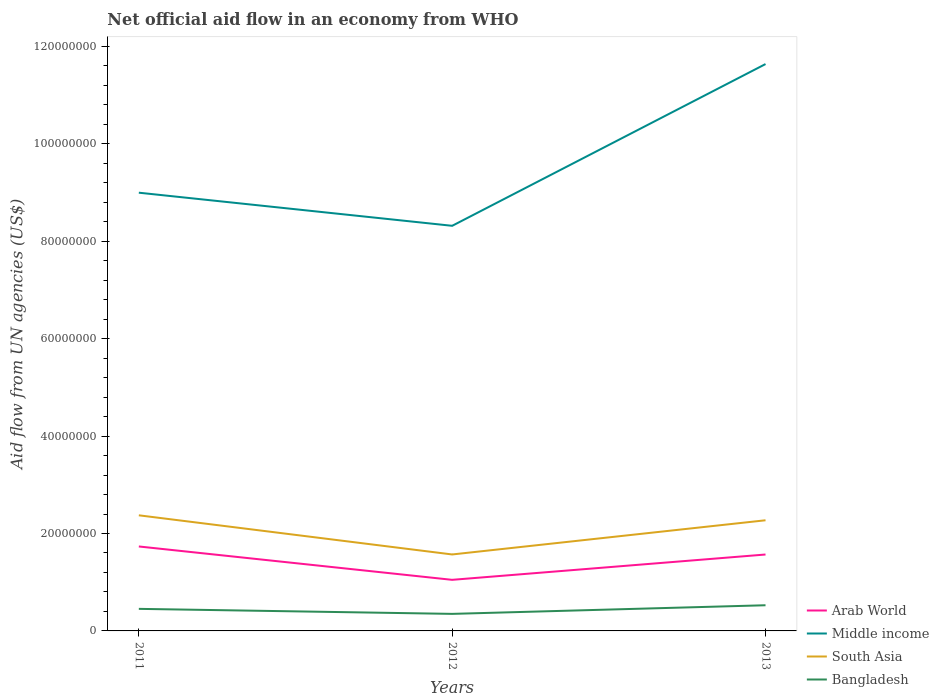Is the number of lines equal to the number of legend labels?
Give a very brief answer. Yes. Across all years, what is the maximum net official aid flow in Bangladesh?
Offer a terse response. 3.50e+06. What is the total net official aid flow in South Asia in the graph?
Give a very brief answer. -7.02e+06. What is the difference between the highest and the second highest net official aid flow in South Asia?
Your response must be concise. 8.04e+06. What is the difference between the highest and the lowest net official aid flow in Arab World?
Offer a very short reply. 2. Is the net official aid flow in Middle income strictly greater than the net official aid flow in South Asia over the years?
Your response must be concise. No. How many lines are there?
Provide a short and direct response. 4. How many years are there in the graph?
Give a very brief answer. 3. Does the graph contain grids?
Give a very brief answer. No. How are the legend labels stacked?
Your answer should be compact. Vertical. What is the title of the graph?
Your answer should be very brief. Net official aid flow in an economy from WHO. Does "St. Martin (French part)" appear as one of the legend labels in the graph?
Your answer should be very brief. No. What is the label or title of the Y-axis?
Ensure brevity in your answer.  Aid flow from UN agencies (US$). What is the Aid flow from UN agencies (US$) of Arab World in 2011?
Ensure brevity in your answer.  1.73e+07. What is the Aid flow from UN agencies (US$) in Middle income in 2011?
Offer a very short reply. 9.00e+07. What is the Aid flow from UN agencies (US$) of South Asia in 2011?
Your answer should be very brief. 2.37e+07. What is the Aid flow from UN agencies (US$) in Bangladesh in 2011?
Ensure brevity in your answer.  4.53e+06. What is the Aid flow from UN agencies (US$) in Arab World in 2012?
Offer a terse response. 1.05e+07. What is the Aid flow from UN agencies (US$) in Middle income in 2012?
Keep it short and to the point. 8.32e+07. What is the Aid flow from UN agencies (US$) in South Asia in 2012?
Provide a succinct answer. 1.57e+07. What is the Aid flow from UN agencies (US$) of Bangladesh in 2012?
Offer a very short reply. 3.50e+06. What is the Aid flow from UN agencies (US$) in Arab World in 2013?
Offer a very short reply. 1.57e+07. What is the Aid flow from UN agencies (US$) of Middle income in 2013?
Keep it short and to the point. 1.16e+08. What is the Aid flow from UN agencies (US$) of South Asia in 2013?
Ensure brevity in your answer.  2.27e+07. What is the Aid flow from UN agencies (US$) of Bangladesh in 2013?
Ensure brevity in your answer.  5.27e+06. Across all years, what is the maximum Aid flow from UN agencies (US$) in Arab World?
Your answer should be very brief. 1.73e+07. Across all years, what is the maximum Aid flow from UN agencies (US$) in Middle income?
Your answer should be compact. 1.16e+08. Across all years, what is the maximum Aid flow from UN agencies (US$) of South Asia?
Your answer should be very brief. 2.37e+07. Across all years, what is the maximum Aid flow from UN agencies (US$) of Bangladesh?
Offer a terse response. 5.27e+06. Across all years, what is the minimum Aid flow from UN agencies (US$) in Arab World?
Keep it short and to the point. 1.05e+07. Across all years, what is the minimum Aid flow from UN agencies (US$) of Middle income?
Ensure brevity in your answer.  8.32e+07. Across all years, what is the minimum Aid flow from UN agencies (US$) in South Asia?
Offer a terse response. 1.57e+07. Across all years, what is the minimum Aid flow from UN agencies (US$) in Bangladesh?
Keep it short and to the point. 3.50e+06. What is the total Aid flow from UN agencies (US$) in Arab World in the graph?
Your answer should be very brief. 4.35e+07. What is the total Aid flow from UN agencies (US$) in Middle income in the graph?
Offer a very short reply. 2.90e+08. What is the total Aid flow from UN agencies (US$) of South Asia in the graph?
Offer a very short reply. 6.22e+07. What is the total Aid flow from UN agencies (US$) in Bangladesh in the graph?
Ensure brevity in your answer.  1.33e+07. What is the difference between the Aid flow from UN agencies (US$) of Arab World in 2011 and that in 2012?
Give a very brief answer. 6.85e+06. What is the difference between the Aid flow from UN agencies (US$) in Middle income in 2011 and that in 2012?
Provide a short and direct response. 6.80e+06. What is the difference between the Aid flow from UN agencies (US$) in South Asia in 2011 and that in 2012?
Keep it short and to the point. 8.04e+06. What is the difference between the Aid flow from UN agencies (US$) in Bangladesh in 2011 and that in 2012?
Provide a short and direct response. 1.03e+06. What is the difference between the Aid flow from UN agencies (US$) of Arab World in 2011 and that in 2013?
Keep it short and to the point. 1.65e+06. What is the difference between the Aid flow from UN agencies (US$) in Middle income in 2011 and that in 2013?
Make the answer very short. -2.64e+07. What is the difference between the Aid flow from UN agencies (US$) of South Asia in 2011 and that in 2013?
Provide a short and direct response. 1.02e+06. What is the difference between the Aid flow from UN agencies (US$) in Bangladesh in 2011 and that in 2013?
Ensure brevity in your answer.  -7.40e+05. What is the difference between the Aid flow from UN agencies (US$) of Arab World in 2012 and that in 2013?
Your response must be concise. -5.20e+06. What is the difference between the Aid flow from UN agencies (US$) in Middle income in 2012 and that in 2013?
Keep it short and to the point. -3.32e+07. What is the difference between the Aid flow from UN agencies (US$) of South Asia in 2012 and that in 2013?
Your answer should be very brief. -7.02e+06. What is the difference between the Aid flow from UN agencies (US$) of Bangladesh in 2012 and that in 2013?
Provide a succinct answer. -1.77e+06. What is the difference between the Aid flow from UN agencies (US$) in Arab World in 2011 and the Aid flow from UN agencies (US$) in Middle income in 2012?
Your answer should be compact. -6.58e+07. What is the difference between the Aid flow from UN agencies (US$) of Arab World in 2011 and the Aid flow from UN agencies (US$) of South Asia in 2012?
Give a very brief answer. 1.64e+06. What is the difference between the Aid flow from UN agencies (US$) of Arab World in 2011 and the Aid flow from UN agencies (US$) of Bangladesh in 2012?
Make the answer very short. 1.38e+07. What is the difference between the Aid flow from UN agencies (US$) in Middle income in 2011 and the Aid flow from UN agencies (US$) in South Asia in 2012?
Your response must be concise. 7.43e+07. What is the difference between the Aid flow from UN agencies (US$) of Middle income in 2011 and the Aid flow from UN agencies (US$) of Bangladesh in 2012?
Make the answer very short. 8.65e+07. What is the difference between the Aid flow from UN agencies (US$) in South Asia in 2011 and the Aid flow from UN agencies (US$) in Bangladesh in 2012?
Offer a very short reply. 2.02e+07. What is the difference between the Aid flow from UN agencies (US$) in Arab World in 2011 and the Aid flow from UN agencies (US$) in Middle income in 2013?
Provide a succinct answer. -9.90e+07. What is the difference between the Aid flow from UN agencies (US$) in Arab World in 2011 and the Aid flow from UN agencies (US$) in South Asia in 2013?
Give a very brief answer. -5.38e+06. What is the difference between the Aid flow from UN agencies (US$) in Arab World in 2011 and the Aid flow from UN agencies (US$) in Bangladesh in 2013?
Offer a terse response. 1.21e+07. What is the difference between the Aid flow from UN agencies (US$) of Middle income in 2011 and the Aid flow from UN agencies (US$) of South Asia in 2013?
Your answer should be compact. 6.73e+07. What is the difference between the Aid flow from UN agencies (US$) in Middle income in 2011 and the Aid flow from UN agencies (US$) in Bangladesh in 2013?
Offer a terse response. 8.47e+07. What is the difference between the Aid flow from UN agencies (US$) of South Asia in 2011 and the Aid flow from UN agencies (US$) of Bangladesh in 2013?
Provide a short and direct response. 1.85e+07. What is the difference between the Aid flow from UN agencies (US$) of Arab World in 2012 and the Aid flow from UN agencies (US$) of Middle income in 2013?
Provide a short and direct response. -1.06e+08. What is the difference between the Aid flow from UN agencies (US$) of Arab World in 2012 and the Aid flow from UN agencies (US$) of South Asia in 2013?
Give a very brief answer. -1.22e+07. What is the difference between the Aid flow from UN agencies (US$) of Arab World in 2012 and the Aid flow from UN agencies (US$) of Bangladesh in 2013?
Give a very brief answer. 5.22e+06. What is the difference between the Aid flow from UN agencies (US$) in Middle income in 2012 and the Aid flow from UN agencies (US$) in South Asia in 2013?
Ensure brevity in your answer.  6.05e+07. What is the difference between the Aid flow from UN agencies (US$) of Middle income in 2012 and the Aid flow from UN agencies (US$) of Bangladesh in 2013?
Give a very brief answer. 7.79e+07. What is the difference between the Aid flow from UN agencies (US$) of South Asia in 2012 and the Aid flow from UN agencies (US$) of Bangladesh in 2013?
Offer a terse response. 1.04e+07. What is the average Aid flow from UN agencies (US$) in Arab World per year?
Your answer should be very brief. 1.45e+07. What is the average Aid flow from UN agencies (US$) in Middle income per year?
Your answer should be very brief. 9.65e+07. What is the average Aid flow from UN agencies (US$) in South Asia per year?
Offer a terse response. 2.07e+07. What is the average Aid flow from UN agencies (US$) in Bangladesh per year?
Your answer should be compact. 4.43e+06. In the year 2011, what is the difference between the Aid flow from UN agencies (US$) in Arab World and Aid flow from UN agencies (US$) in Middle income?
Your answer should be compact. -7.26e+07. In the year 2011, what is the difference between the Aid flow from UN agencies (US$) in Arab World and Aid flow from UN agencies (US$) in South Asia?
Give a very brief answer. -6.40e+06. In the year 2011, what is the difference between the Aid flow from UN agencies (US$) of Arab World and Aid flow from UN agencies (US$) of Bangladesh?
Ensure brevity in your answer.  1.28e+07. In the year 2011, what is the difference between the Aid flow from UN agencies (US$) of Middle income and Aid flow from UN agencies (US$) of South Asia?
Keep it short and to the point. 6.62e+07. In the year 2011, what is the difference between the Aid flow from UN agencies (US$) of Middle income and Aid flow from UN agencies (US$) of Bangladesh?
Your answer should be compact. 8.54e+07. In the year 2011, what is the difference between the Aid flow from UN agencies (US$) of South Asia and Aid flow from UN agencies (US$) of Bangladesh?
Provide a short and direct response. 1.92e+07. In the year 2012, what is the difference between the Aid flow from UN agencies (US$) in Arab World and Aid flow from UN agencies (US$) in Middle income?
Make the answer very short. -7.27e+07. In the year 2012, what is the difference between the Aid flow from UN agencies (US$) of Arab World and Aid flow from UN agencies (US$) of South Asia?
Your response must be concise. -5.21e+06. In the year 2012, what is the difference between the Aid flow from UN agencies (US$) in Arab World and Aid flow from UN agencies (US$) in Bangladesh?
Ensure brevity in your answer.  6.99e+06. In the year 2012, what is the difference between the Aid flow from UN agencies (US$) in Middle income and Aid flow from UN agencies (US$) in South Asia?
Ensure brevity in your answer.  6.75e+07. In the year 2012, what is the difference between the Aid flow from UN agencies (US$) in Middle income and Aid flow from UN agencies (US$) in Bangladesh?
Your answer should be very brief. 7.97e+07. In the year 2012, what is the difference between the Aid flow from UN agencies (US$) in South Asia and Aid flow from UN agencies (US$) in Bangladesh?
Keep it short and to the point. 1.22e+07. In the year 2013, what is the difference between the Aid flow from UN agencies (US$) in Arab World and Aid flow from UN agencies (US$) in Middle income?
Your answer should be compact. -1.01e+08. In the year 2013, what is the difference between the Aid flow from UN agencies (US$) in Arab World and Aid flow from UN agencies (US$) in South Asia?
Ensure brevity in your answer.  -7.03e+06. In the year 2013, what is the difference between the Aid flow from UN agencies (US$) in Arab World and Aid flow from UN agencies (US$) in Bangladesh?
Keep it short and to the point. 1.04e+07. In the year 2013, what is the difference between the Aid flow from UN agencies (US$) in Middle income and Aid flow from UN agencies (US$) in South Asia?
Your answer should be very brief. 9.37e+07. In the year 2013, what is the difference between the Aid flow from UN agencies (US$) of Middle income and Aid flow from UN agencies (US$) of Bangladesh?
Your response must be concise. 1.11e+08. In the year 2013, what is the difference between the Aid flow from UN agencies (US$) of South Asia and Aid flow from UN agencies (US$) of Bangladesh?
Provide a succinct answer. 1.74e+07. What is the ratio of the Aid flow from UN agencies (US$) of Arab World in 2011 to that in 2012?
Provide a short and direct response. 1.65. What is the ratio of the Aid flow from UN agencies (US$) in Middle income in 2011 to that in 2012?
Your answer should be very brief. 1.08. What is the ratio of the Aid flow from UN agencies (US$) of South Asia in 2011 to that in 2012?
Provide a short and direct response. 1.51. What is the ratio of the Aid flow from UN agencies (US$) in Bangladesh in 2011 to that in 2012?
Offer a terse response. 1.29. What is the ratio of the Aid flow from UN agencies (US$) in Arab World in 2011 to that in 2013?
Provide a short and direct response. 1.11. What is the ratio of the Aid flow from UN agencies (US$) in Middle income in 2011 to that in 2013?
Offer a terse response. 0.77. What is the ratio of the Aid flow from UN agencies (US$) of South Asia in 2011 to that in 2013?
Your response must be concise. 1.04. What is the ratio of the Aid flow from UN agencies (US$) in Bangladesh in 2011 to that in 2013?
Your answer should be very brief. 0.86. What is the ratio of the Aid flow from UN agencies (US$) of Arab World in 2012 to that in 2013?
Your response must be concise. 0.67. What is the ratio of the Aid flow from UN agencies (US$) of Middle income in 2012 to that in 2013?
Your response must be concise. 0.71. What is the ratio of the Aid flow from UN agencies (US$) of South Asia in 2012 to that in 2013?
Offer a very short reply. 0.69. What is the ratio of the Aid flow from UN agencies (US$) of Bangladesh in 2012 to that in 2013?
Your response must be concise. 0.66. What is the difference between the highest and the second highest Aid flow from UN agencies (US$) of Arab World?
Your answer should be compact. 1.65e+06. What is the difference between the highest and the second highest Aid flow from UN agencies (US$) in Middle income?
Provide a succinct answer. 2.64e+07. What is the difference between the highest and the second highest Aid flow from UN agencies (US$) in South Asia?
Provide a short and direct response. 1.02e+06. What is the difference between the highest and the second highest Aid flow from UN agencies (US$) in Bangladesh?
Provide a succinct answer. 7.40e+05. What is the difference between the highest and the lowest Aid flow from UN agencies (US$) of Arab World?
Keep it short and to the point. 6.85e+06. What is the difference between the highest and the lowest Aid flow from UN agencies (US$) of Middle income?
Ensure brevity in your answer.  3.32e+07. What is the difference between the highest and the lowest Aid flow from UN agencies (US$) in South Asia?
Your answer should be compact. 8.04e+06. What is the difference between the highest and the lowest Aid flow from UN agencies (US$) of Bangladesh?
Offer a terse response. 1.77e+06. 